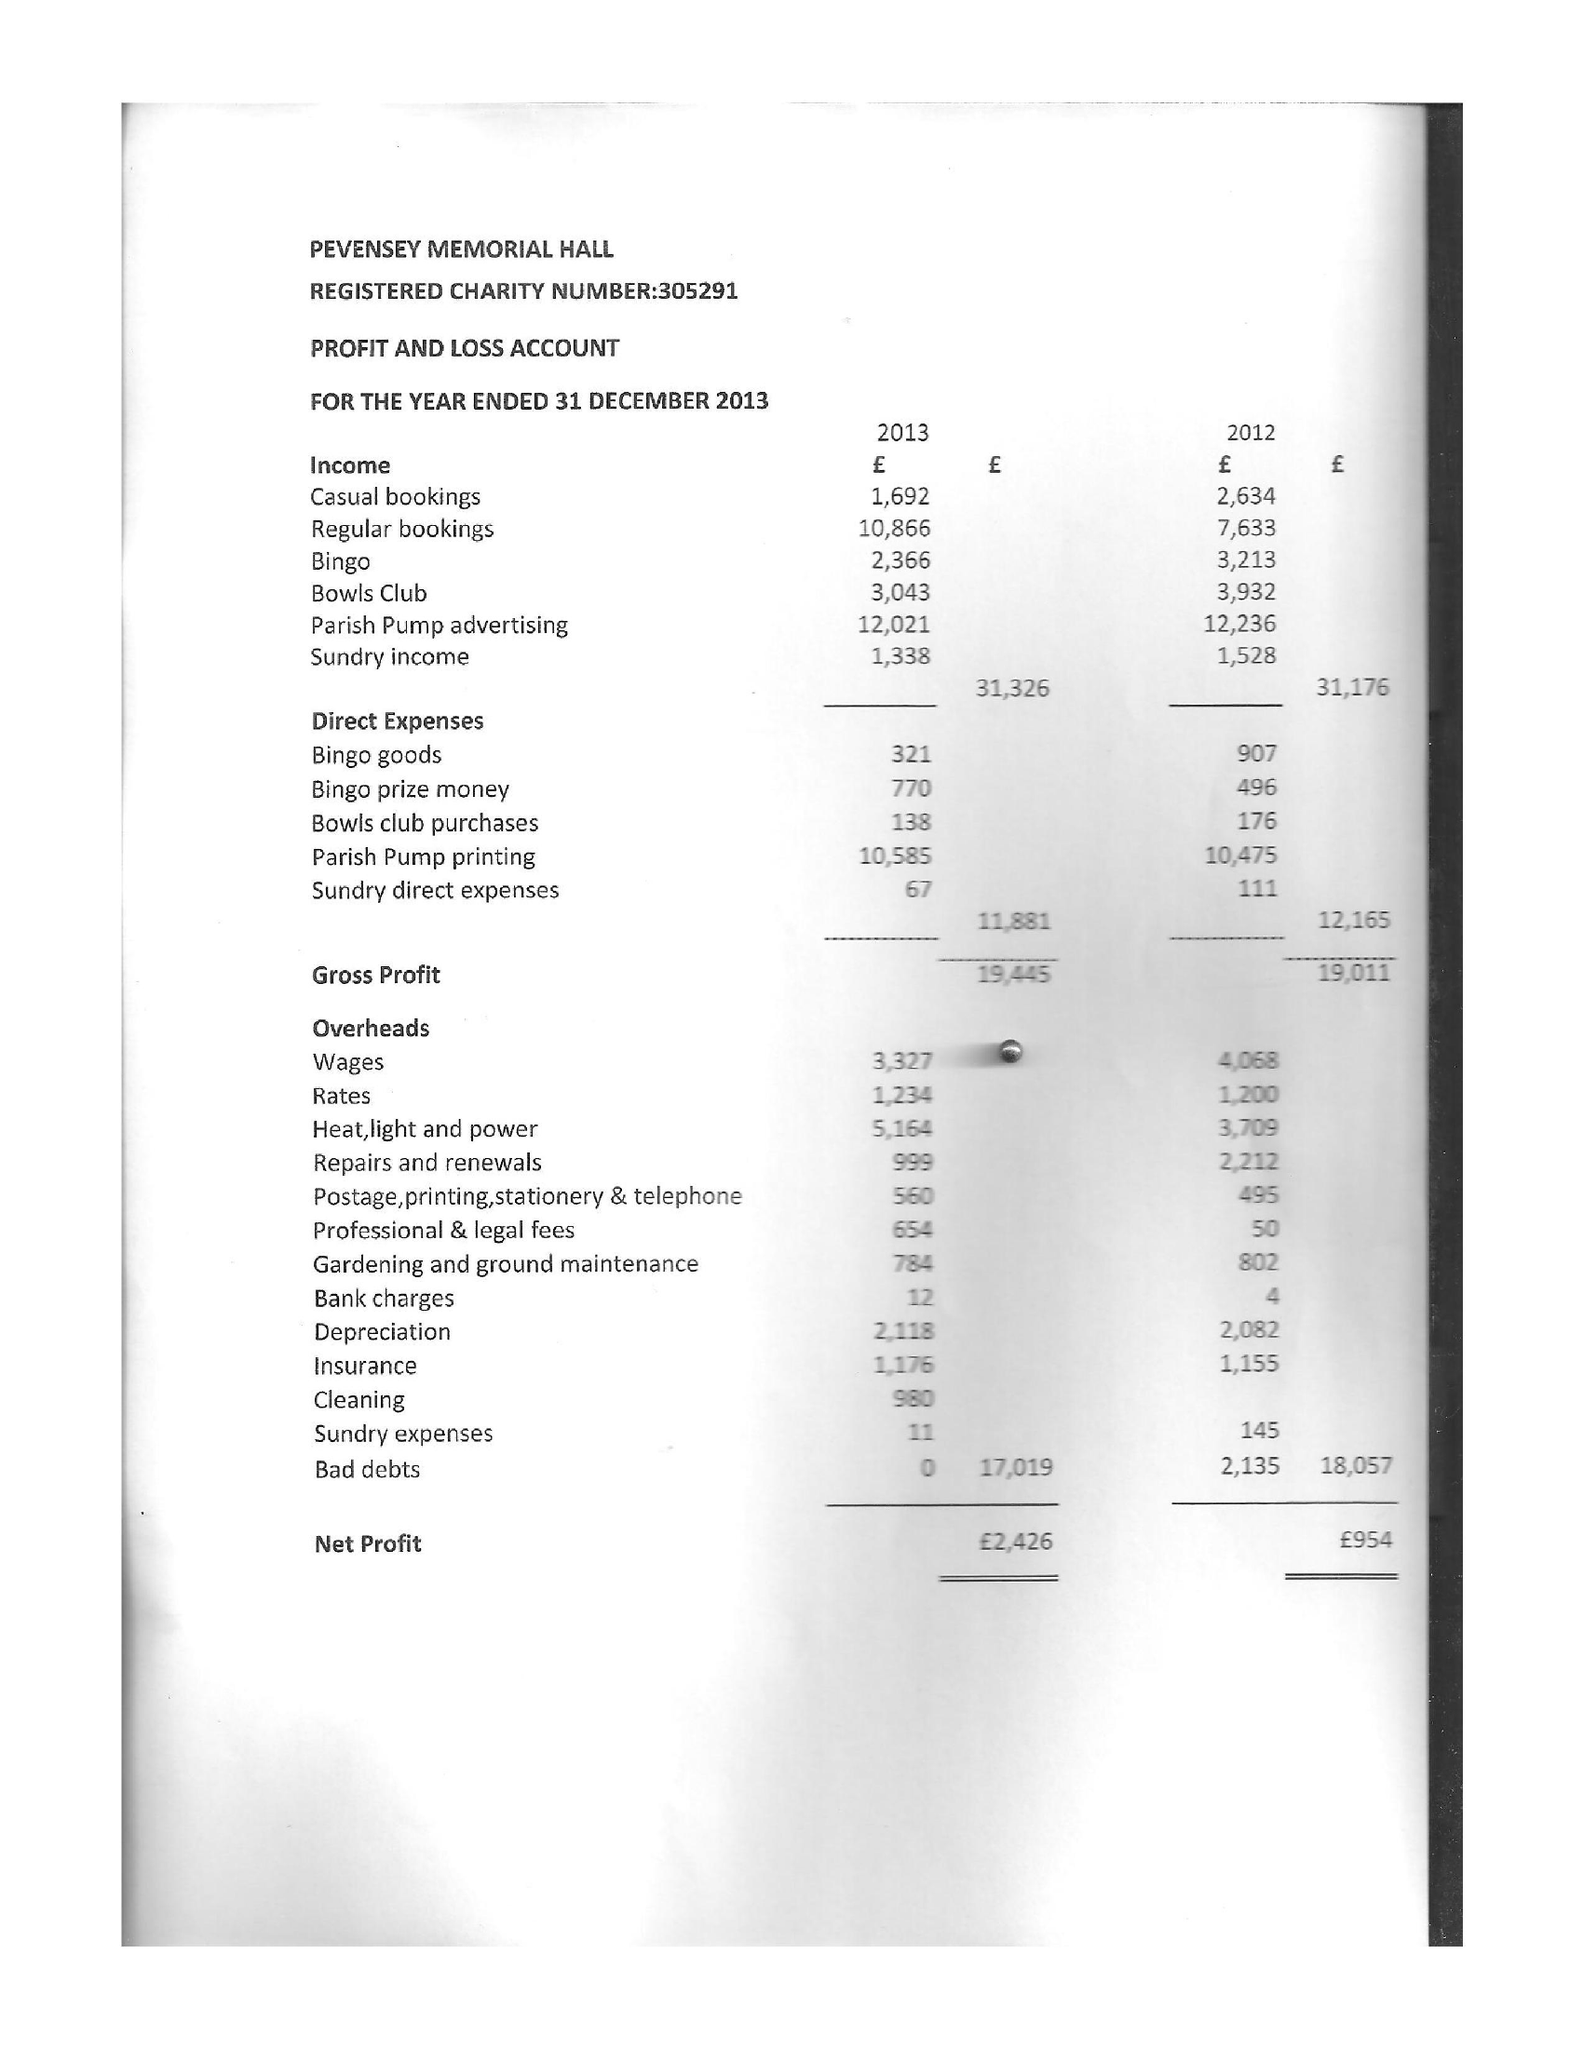What is the value for the address__street_line?
Answer the question using a single word or phrase. 63 INNINGS DRIVE 